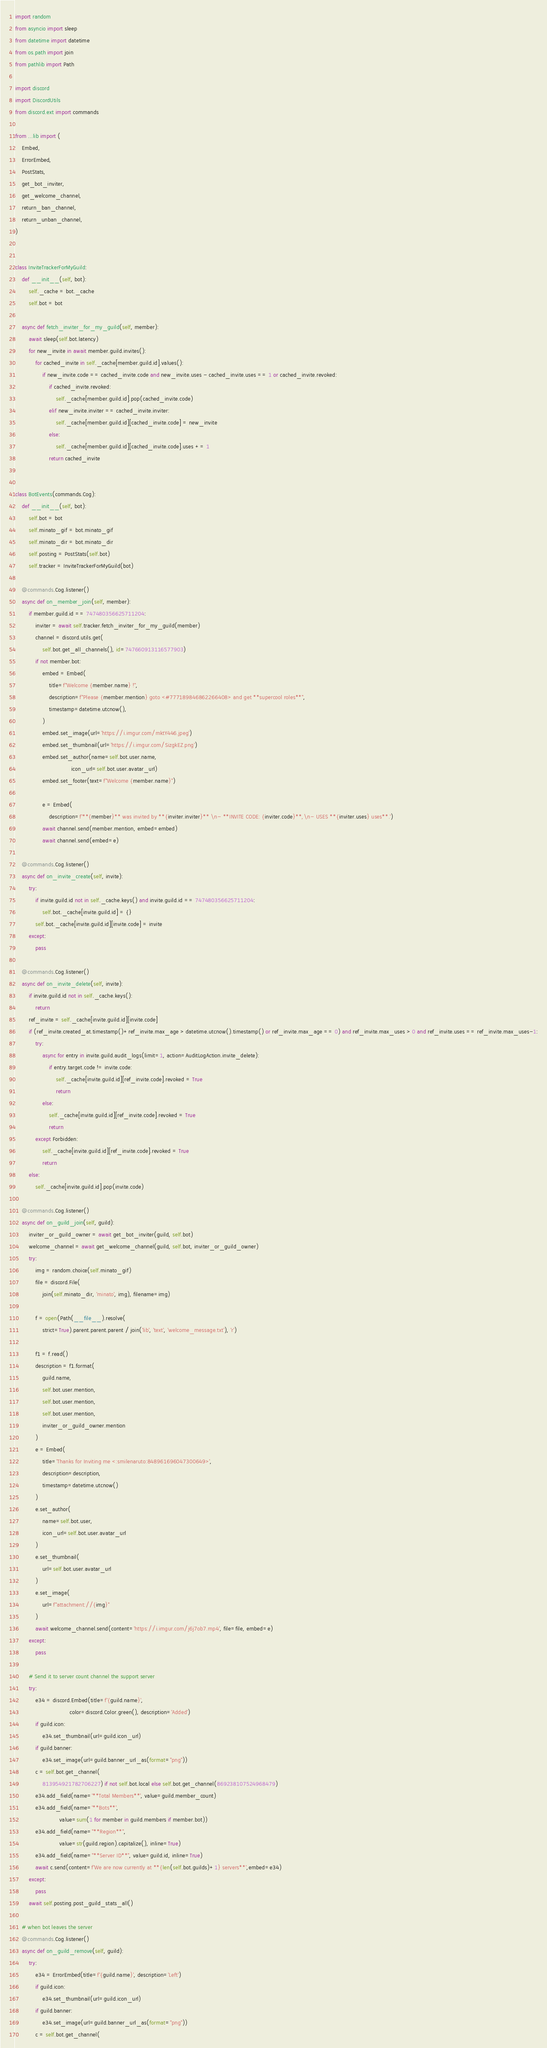Convert code to text. <code><loc_0><loc_0><loc_500><loc_500><_Python_>import random
from asyncio import sleep
from datetime import datetime
from os.path import join
from pathlib import Path

import discord
import DiscordUtils
from discord.ext import commands

from ...lib import (
    Embed,
    ErrorEmbed,
    PostStats,
    get_bot_inviter,
    get_welcome_channel,
    return_ban_channel,
    return_unban_channel,
)


class InviteTrackerForMyGuild:
    def __init__(self, bot):
        self._cache = bot._cache
        self.bot = bot

    async def fetch_inviter_for_my_guild(self, member):
        await sleep(self.bot.latency)
        for new_invite in await member.guild.invites():
            for cached_invite in self._cache[member.guild.id].values():
                if new_invite.code == cached_invite.code and new_invite.uses - cached_invite.uses == 1 or cached_invite.revoked:
                    if cached_invite.revoked:
                        self._cache[member.guild.id].pop(cached_invite.code)
                    elif new_invite.inviter == cached_invite.inviter:
                        self._cache[member.guild.id][cached_invite.code] = new_invite
                    else:
                        self._cache[member.guild.id][cached_invite.code].uses += 1
                    return cached_invite


class BotEvents(commands.Cog):
    def __init__(self, bot):
        self.bot = bot
        self.minato_gif = bot.minato_gif
        self.minato_dir = bot.minato_dir
        self.posting = PostStats(self.bot)
        self.tracker = InviteTrackerForMyGuild(bot)   

    @commands.Cog.listener()
    async def on_member_join(self, member):
        if member.guild.id == 747480356625711204:
            inviter = await self.tracker.fetch_inviter_for_my_guild(member)
            channel = discord.utils.get(
                self.bot.get_all_channels(), id=747660913116577903)
            if not member.bot:
                embed = Embed(
                    title=f"Welcome {member.name} !",
                    description=f"Please {member.mention} goto <#777189846862266408> and get **supercool roles**",
                    timestamp=datetime.utcnow(),
                )
                embed.set_image(url='https://i.imgur.com/mktY446.jpeg')
                embed.set_thumbnail(url='https://i.imgur.com/SizgkEZ.png')
                embed.set_author(name=self.bot.user.name,
                                 icon_url=self.bot.user.avatar_url)
                embed.set_footer(text=f"Welcome {member.name}")

                e = Embed(
                    description=f'**{member}** was invited by **{inviter.inviter}** \n- **INVITE CODE: {inviter.code}**,\n- USES **{inviter.uses} uses**.')
                await channel.send(member.mention, embed=embed)
                await channel.send(embed=e)

    @commands.Cog.listener()
    async def on_invite_create(self, invite):
        try:
            if invite.guild.id not in self._cache.keys() and invite.guild.id == 747480356625711204:
                self.bot._cache[invite.guild.id] = {}
            self.bot._cache[invite.guild.id][invite.code] = invite
        except:
            pass

    @commands.Cog.listener()
    async def on_invite_delete(self, invite):
        if invite.guild.id not in self._cache.keys():
            return
        ref_invite = self._cache[invite.guild.id][invite.code]
        if (ref_invite.created_at.timestamp()+ref_invite.max_age > datetime.utcnow().timestamp() or ref_invite.max_age == 0) and ref_invite.max_uses > 0 and ref_invite.uses == ref_invite.max_uses-1:
            try:
                async for entry in invite.guild.audit_logs(limit=1, action=AuditLogAction.invite_delete):
                    if entry.target.code != invite.code:
                        self._cache[invite.guild.id][ref_invite.code].revoked = True
                        return
                else:
                    self._cache[invite.guild.id][ref_invite.code].revoked = True
                    return
            except Forbidden:
                self._cache[invite.guild.id][ref_invite.code].revoked = True
                return
        else:
            self._cache[invite.guild.id].pop(invite.code)

    @commands.Cog.listener()
    async def on_guild_join(self, guild):
        inviter_or_guild_owner = await get_bot_inviter(guild, self.bot)
        welcome_channel = await get_welcome_channel(guild, self.bot, inviter_or_guild_owner)
        try:
            img = random.choice(self.minato_gif)
            file = discord.File(
                join(self.minato_dir, 'minato', img), filename=img)
            
            f = open(Path(__file__).resolve(
                strict=True).parent.parent.parent / join('lib', 'text', 'welcome_message.txt'), 'r')

            f1 = f.read()
            description = f1.format(
                guild.name,
                self.bot.user.mention,
                self.bot.user.mention,
                self.bot.user.mention,
                inviter_or_guild_owner.mention
            )
            e = Embed(
                title='Thanks for Inviting me <:smilenaruto:848961696047300649>',
                description=description,
                timestamp=datetime.utcnow()
            )
            e.set_author(
                name=self.bot.user,
                icon_url=self.bot.user.avatar_url
            )
            e.set_thumbnail(
                url=self.bot.user.avatar_url
            )
            e.set_image(
                url=f"attachment://{img}"
            )
            await welcome_channel.send(content='https://i.imgur.com/j6j7ob7.mp4', file=file, embed=e)
        except:
            pass

        # Send it to server count channel the support server
        try:
            e34 = discord.Embed(title=f'{guild.name}',
                                color=discord.Color.green(), description='Added')
            if guild.icon:
                e34.set_thumbnail(url=guild.icon_url)
            if guild.banner:
                e34.set_image(url=guild.banner_url_as(format="png"))
            c = self.bot.get_channel(
                813954921782706227) if not self.bot.local else self.bot.get_channel(869238107524968479)
            e34.add_field(name='**Total Members**', value=guild.member_count)
            e34.add_field(name='**Bots**',
                          value=sum(1 for member in guild.members if member.bot))
            e34.add_field(name="**Region**",
                          value=str(guild.region).capitalize(), inline=True)
            e34.add_field(name="**Server ID**", value=guild.id, inline=True)
            await c.send(content=f'We are now currently at **{len(self.bot.guilds)+1} servers**',embed=e34)
        except:
            pass
        await self.posting.post_guild_stats_all()

    # when bot leaves the server
    @commands.Cog.listener()
    async def on_guild_remove(self, guild):
        try:
            e34 = ErrorEmbed(title=f'{guild.name}', description='Left')
            if guild.icon:
                e34.set_thumbnail(url=guild.icon_url)
            if guild.banner:
                e34.set_image(url=guild.banner_url_as(format="png"))
            c = self.bot.get_channel(</code> 